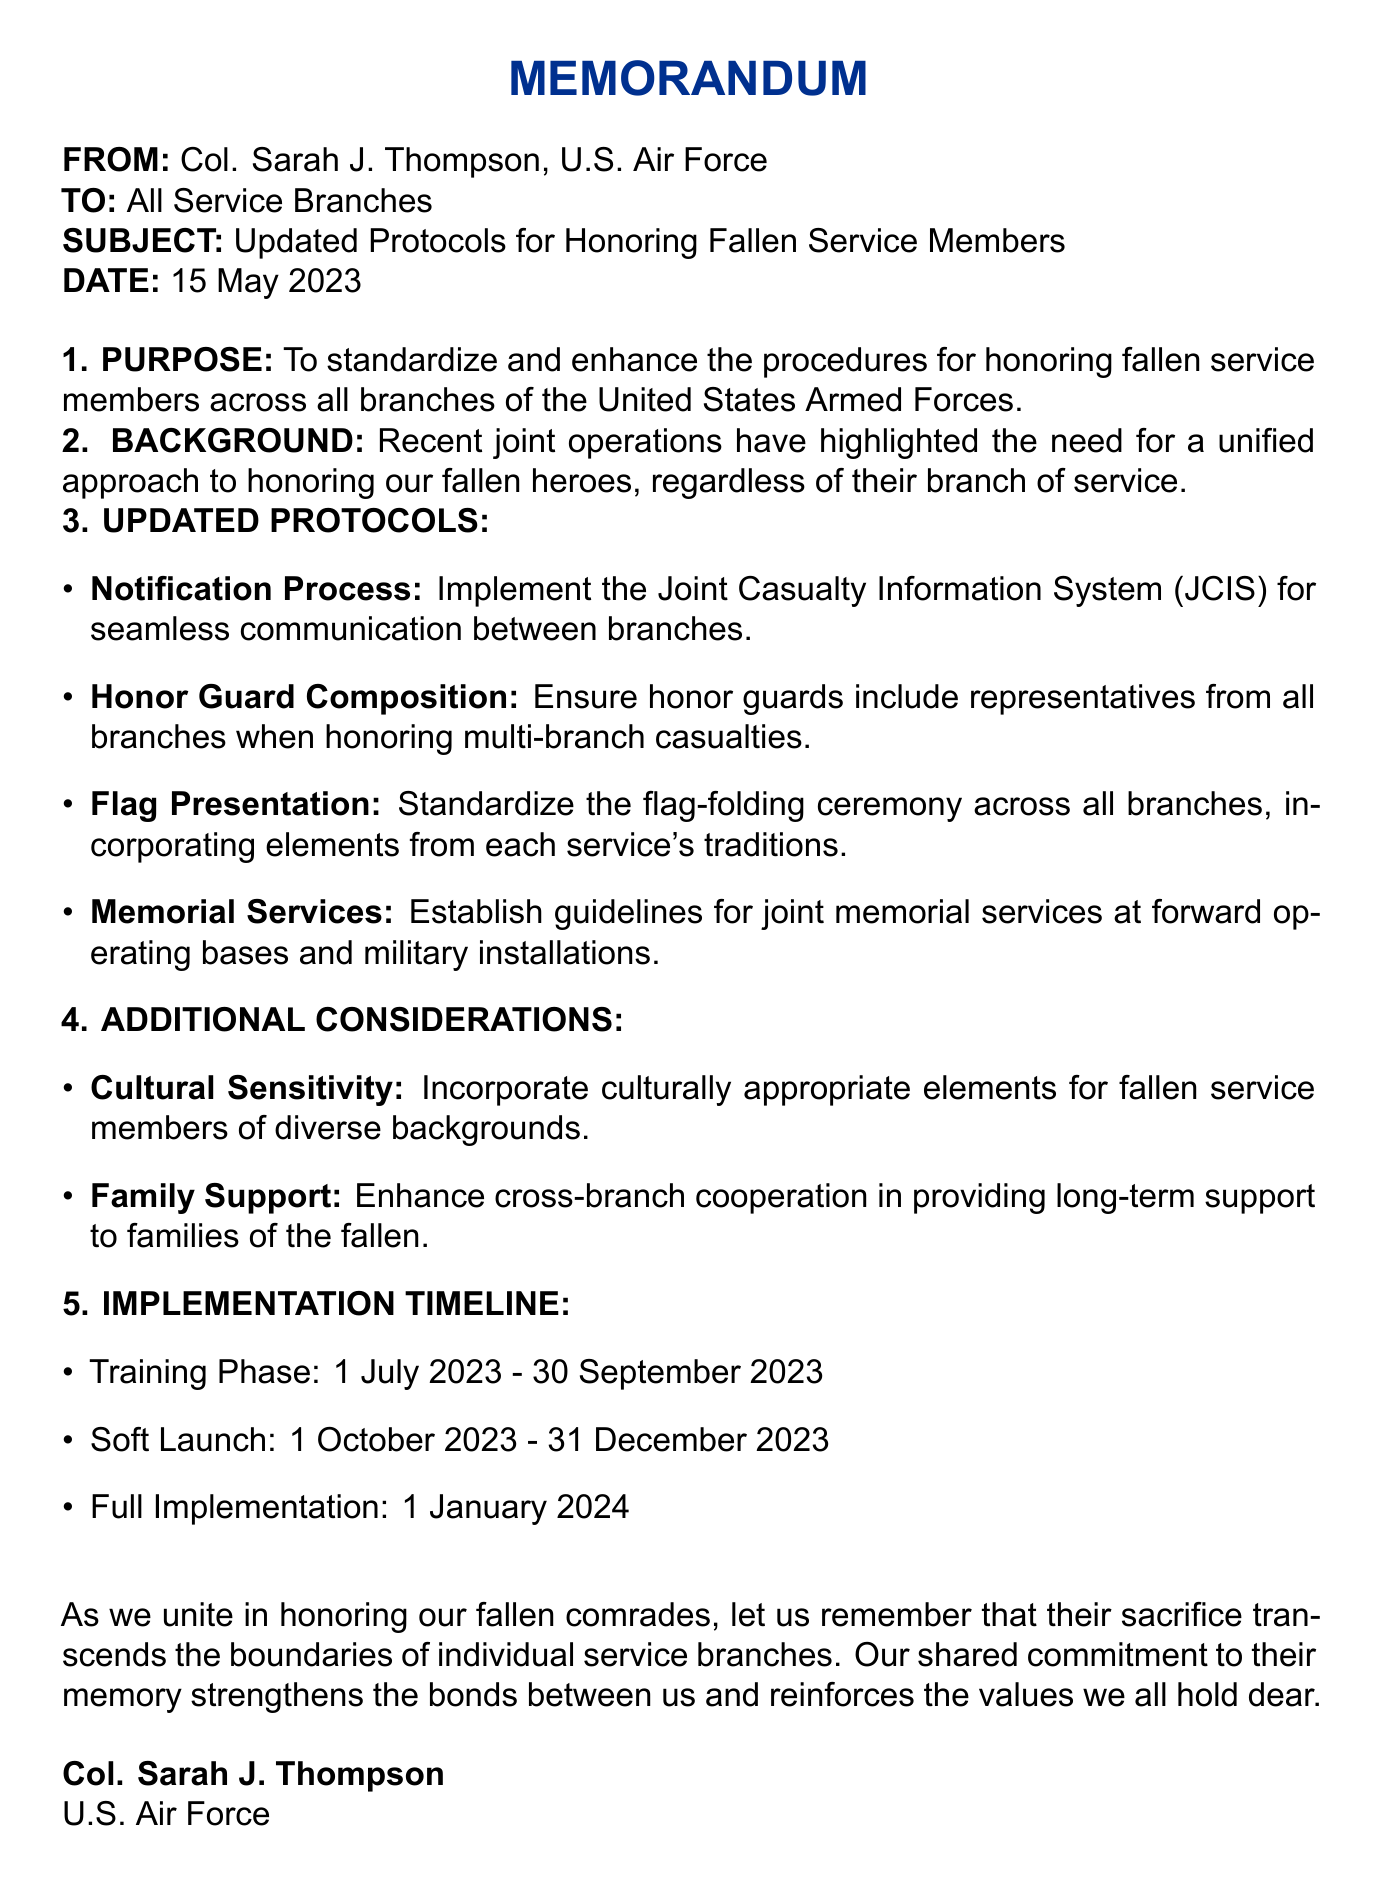what is the date of the memo? The date of the memo is clearly stated in the header section.
Answer: 15 May 2023 who is the author of the memo? The memo identifies the author at the beginning.
Answer: Col. Sarah J. Thompson, U.S. Air Force what is the purpose of the memo? The purpose of the memo is specified in the first section.
Answer: To standardize and enhance the procedures for honoring fallen service members across all branches of the United States Armed Forces which system is being implemented for communication between branches? The memo mentions a specific system for communication in the updated protocols.
Answer: Joint Casualty Information System (JCIS) how long is the training phase for the updated protocols? The timeline section details the duration of the training phase.
Answer: 1 July 2023 - 30 September 2023 what is one of the additional considerations mentioned in the memo? The additional considerations section lists topics that are highlighted for attention.
Answer: Cultural Sensitivity who is responsible for the honor guard composition? Each updated protocol lists the party responsible for implementation.
Answer: Military District of Washington Ceremonial Units when will full implementation of the protocols begin? The implementation timeline specifies when full implementation will occur.
Answer: 1 January 2024 what should be incorporated into the flag presentation ceremony? The updated protocols detail what should be included in the flag presentation.
Answer: Elements from each service's traditions 